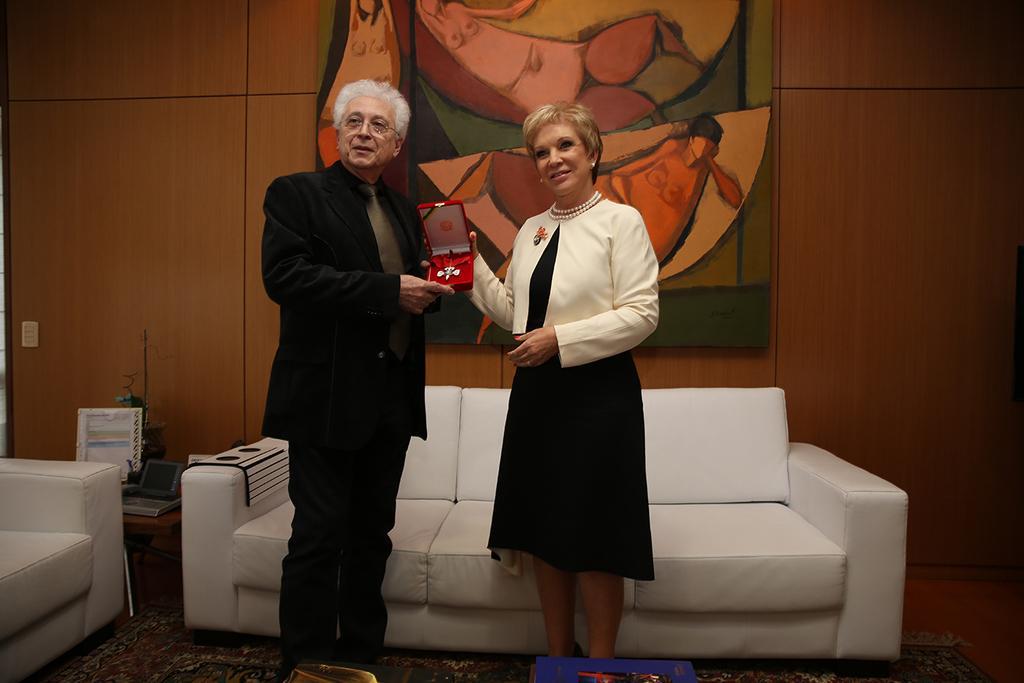How would you summarize this image in a sentence or two? This picture shows a man and a woman standing and holding a ornament in their hands and we see a sofa and a chair and we see a frame on the wall 